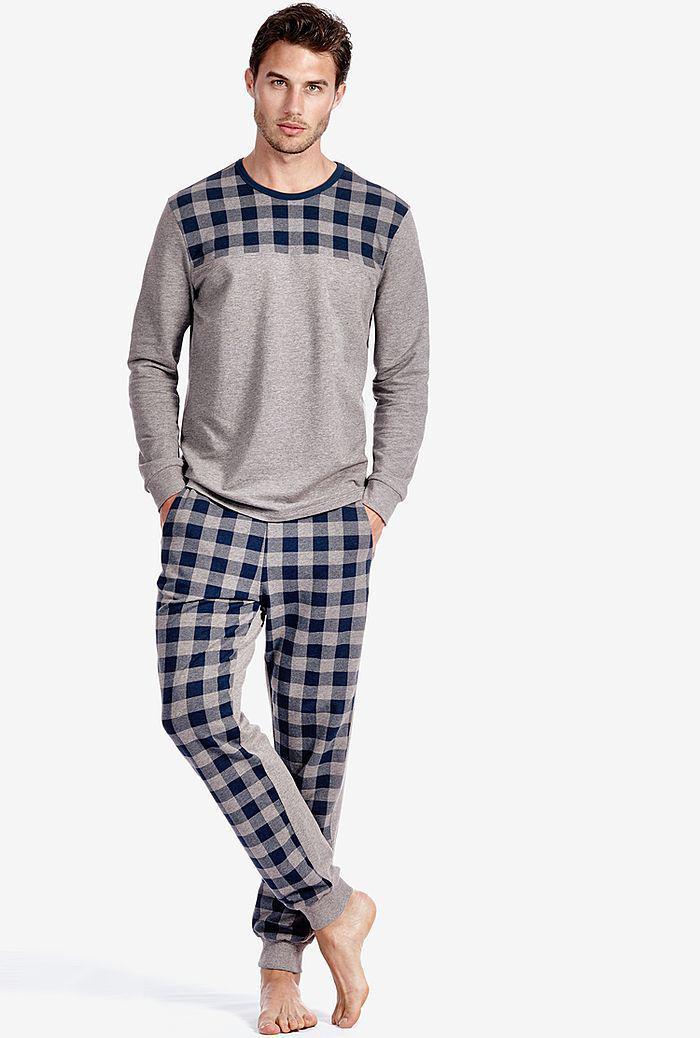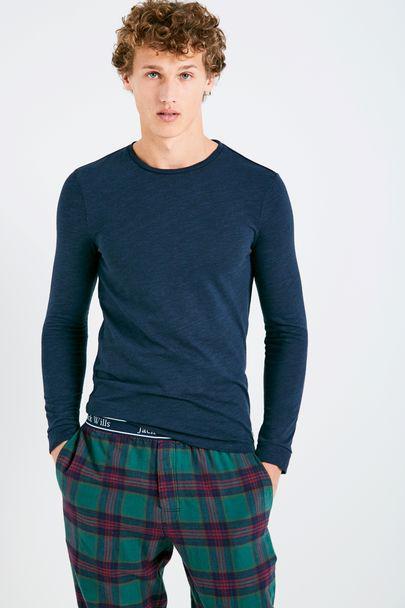The first image is the image on the left, the second image is the image on the right. For the images shown, is this caption "The model on the right wears plaid bottoms and a dark, solid-colored top." true? Answer yes or no. Yes. The first image is the image on the left, the second image is the image on the right. Examine the images to the left and right. Is the description "All photos are full length shots of people modeling clothes." accurate? Answer yes or no. No. 